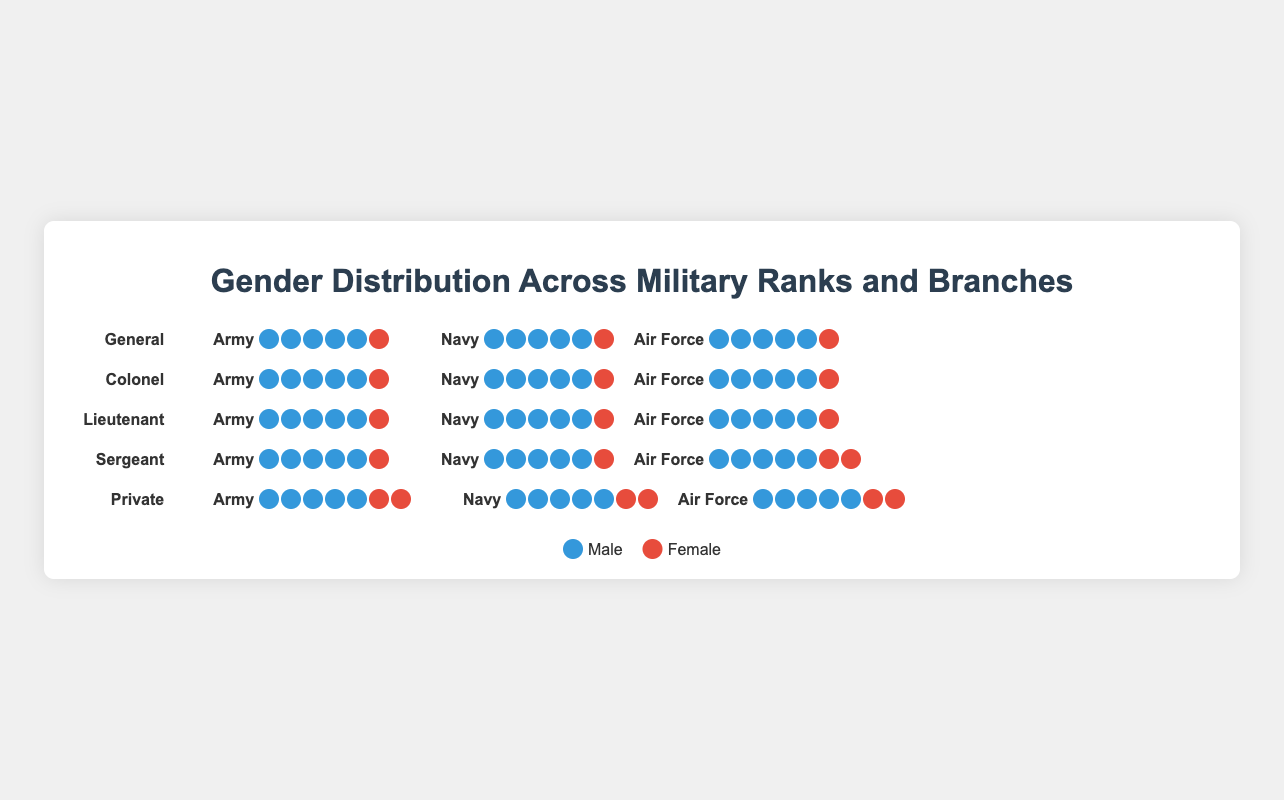What's the title of the figure? The title of the figure is prominently displayed at the top.
Answer: Gender Distribution Across Military Ranks and Branches Which branch has the highest percentage of females for the Private rank? For the Private rank, the Air Force shows the highest number of female icons (6), indicating 30%.
Answer: Air Force What percentage of Generals in the Navy are female? The Navy section for Generals shows 1 female icon out of 20, representing 5%.
Answer: 5% How many female Colonels are there in the Army, Navy, and Air Force combined? Army has 1 female Colonel, Navy has 1 female Colonel, and Air Force has 1 female Colonel, summing up to 1+1+1.
Answer: 3 Which branch has the highest male representation at the General rank? The Army section for Generals shows the highest number of male icons (49), indicating 98%.
Answer: Army Compare the percentage of female Lieutenants in the Army to those in the Air Force. The Army has 10% female Lieutenants (1 female icon), and the Air Force has 20% female Lieutenants (2 female icons). Comparatively, the Air Force has a higher percentage.
Answer: Air Force What is the difference in the number of male Sergeants between the Army and Navy? The Army has 17 male Sergeants and the Navy has 16 male Sergeants. The difference is 17 - 16.
Answer: 1 Which military rank has the lowest representation of females in the Army? Generals in the Army show the lowest number of female icons, just 1, indicating 2%.
Answer: General How does the female representation change from Private to General in the Air Force? Moving from Private (30%) to General (8%) in the Air Force, the percentage decreases significantly, indicating a declining trend in female representation with increasing rank.
Answer: Decreases 